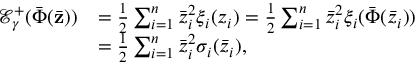Convert formula to latex. <formula><loc_0><loc_0><loc_500><loc_500>\begin{array} { r l } { \mathcal { E } _ { \gamma } ^ { + } ( \bar { \Phi } ( \bar { z } ) ) } & { = \frac { 1 } { 2 } \sum _ { i = 1 } ^ { n } \bar { z } _ { i } ^ { 2 } \xi _ { i } ( z _ { i } ) = \frac { 1 } { 2 } \sum _ { i = 1 } ^ { n } \bar { z } _ { i } ^ { 2 } \xi _ { i } ( \bar { \Phi } ( \bar { z } _ { i } ) ) } \\ & { = \frac { 1 } { 2 } \sum _ { i = 1 } ^ { n } \bar { z } _ { i } ^ { 2 } \sigma _ { i } ( \bar { z } _ { i } ) , } \end{array}</formula> 